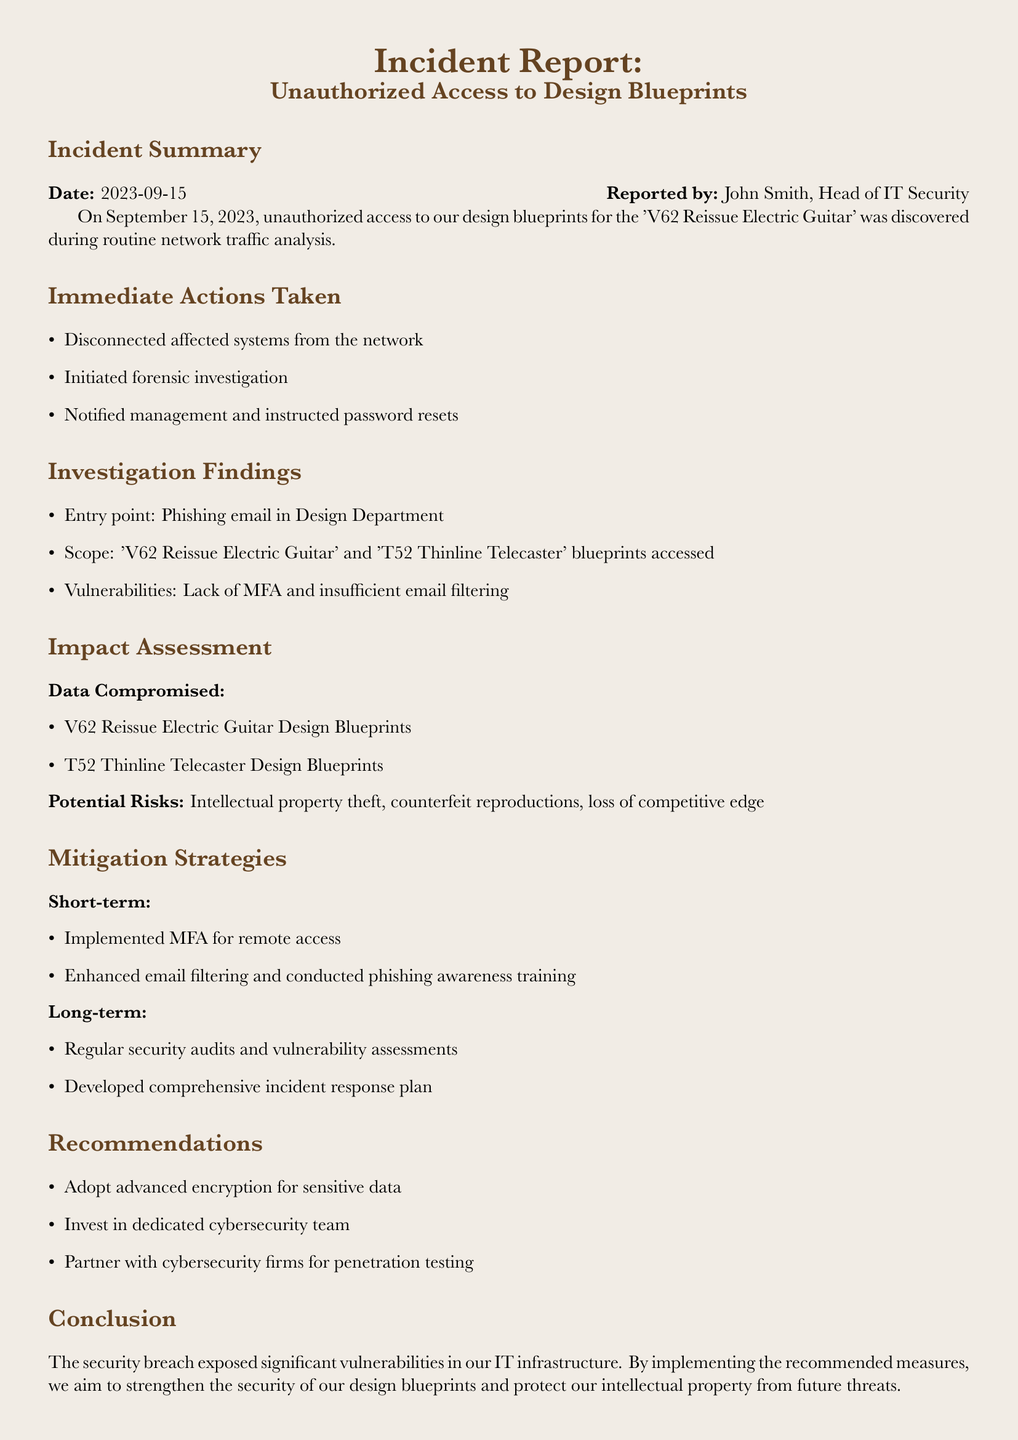What is the date of the incident? The date of the incident is specified in the document as September 15, 2023.
Answer: September 15, 2023 Who reported the incident? The document states that the incident was reported by John Smith, Head of IT Security.
Answer: John Smith What was the primary vulnerability exploited? The findings indicated that the entry point for the unauthorized access was a phishing email in the Design Department.
Answer: Phishing email What design blueprints were compromised? The document lists the design blueprints for the V62 Reissue Electric Guitar and T52 Thinline Telecaster as compromised.
Answer: V62 Reissue Electric Guitar and T52 Thinline Telecaster What immediate action was taken concerning the affected systems? One of the immediate actions detailed in the report was to disconnect affected systems from the network.
Answer: Disconnected affected systems from the network What mitigation strategy was implemented for remote access? The report mentions that multi-factor authentication (MFA) was implemented for remote access as a short-term strategy.
Answer: MFA What is one of the long-term mitigation strategies mentioned? The document suggests that regular security audits and vulnerability assessments are part of the long-term mitigation strategies.
Answer: Regular security audits and vulnerability assessments What potential risk is associated with the data compromise? The report highlights intellectual property theft as a potential risk associated with the data compromise.
Answer: Intellectual property theft What training was conducted following the incident? The document notes that phishing awareness training was conducted as part of the mitigation strategies after the incident.
Answer: Phishing awareness training 